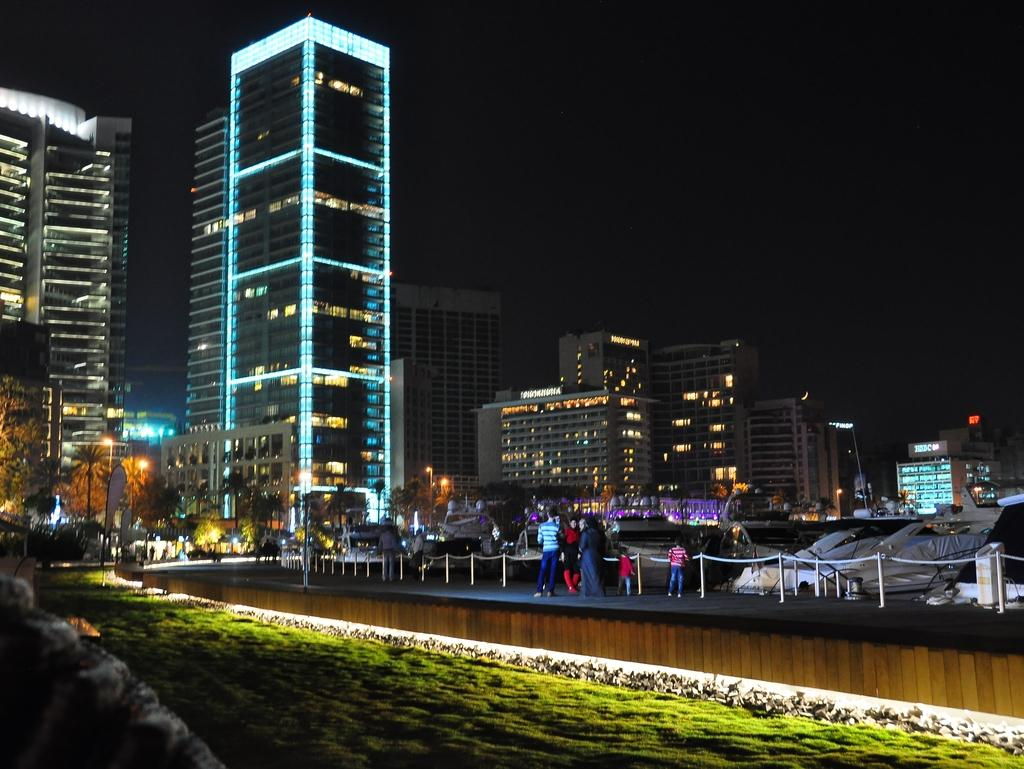What type of vegetation can be seen in the image? There is grass in the image. What natural element is present in the image? There is water in the image. What type of barrier can be seen in the image? There is a fence in the image. Who or what is present in the image? There are people in the image. What type of man-made structures are visible in the image? There are buildings in the image. What type of vertical structures can be seen in the image? There are poles in the image. What type of artificial light sources are visible in the image? There are lights in the image. What type of plant life can be seen in the image? There are trees in the image. What type of objects can be seen in the image? There are some objects in the image. How would you describe the background of the image? The background of the image is dark. Where is the crowd gathered in the image? There is no crowd present in the image. What type of bubble can be seen floating in the image? There are no bubbles present in the image. 